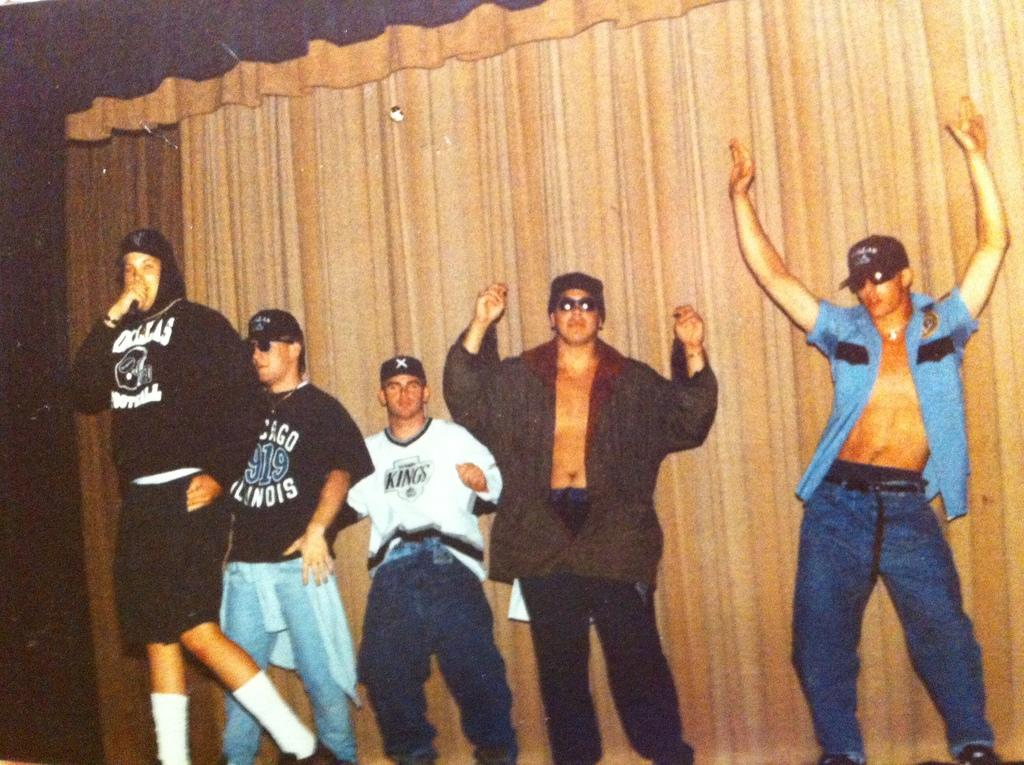<image>
Relay a brief, clear account of the picture shown. People standing together with one wearing a shirt that says Illinois. 